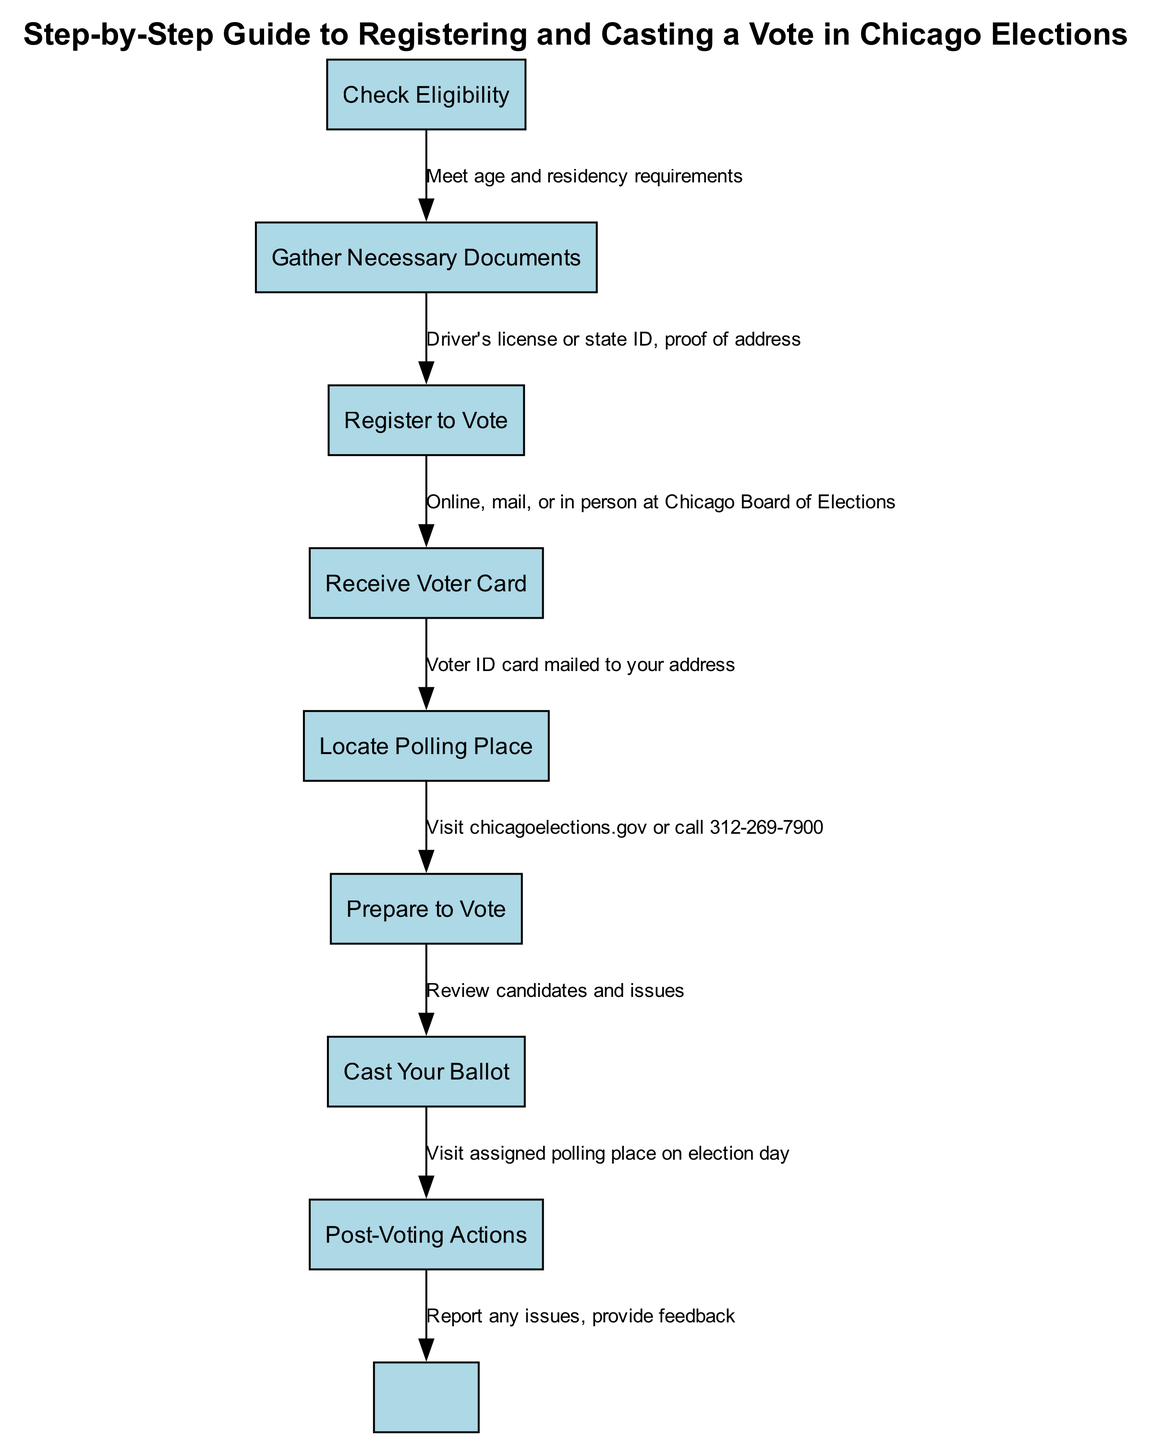What is the first step in the voting process? The first step in the voting process is to "Check Eligibility." This is indicated clearly at the start of the diagram as the initial node.
Answer: Check Eligibility How many nodes are in the diagram? The diagram contains a total of eight nodes, which represent different steps in the voting process. Each unique step is represented by a number on the diagram.
Answer: 8 What documents do you need to register to vote? To register to vote, you need a "Driver's license or state ID" and "proof of address." These specific documents are listed as necessary to move from the "Gather Necessary Documents" step to the "Register to Vote" step.
Answer: Driver's license or state ID, proof of address What is sent to your address after registering? After registering to vote, you will receive a "Voter Card" mailed to your address. This outcome is clearly indicated in the connection between the "Register to Vote" and the "Receive Voter Card" nodes.
Answer: Voter Card What action should you take after casting your ballot? After casting your ballot, you should perform "Post-Voting Actions." This step is listed as the final action in the voting process, emphasizing the importance of actions that follow voting.
Answer: Post-Voting Actions What should you do to prepare for voting? To prepare for voting, you should "Review candidates and issues." This information is detailed in the connection between the "Prepare to Vote" node and the next step in the diagram.
Answer: Review candidates and issues How do you locate your polling place? You can locate your polling place by visiting "chicagoelections.gov" or calling "312-269-7900," as specified in the link from the "Locate Polling Place" node to the "Prepare to Vote" node.
Answer: chicagoelections.gov or call 312-269-7900 What is indicated by the edge between nodes "Cast Your Ballot" and "Post-Voting Actions"? The edge between these two nodes indicates the action to be taken after voting, specifically to "Visit assigned polling place on election day." This clearly defines the steps and their sequence in the diagram.
Answer: Visit assigned polling place on election day 